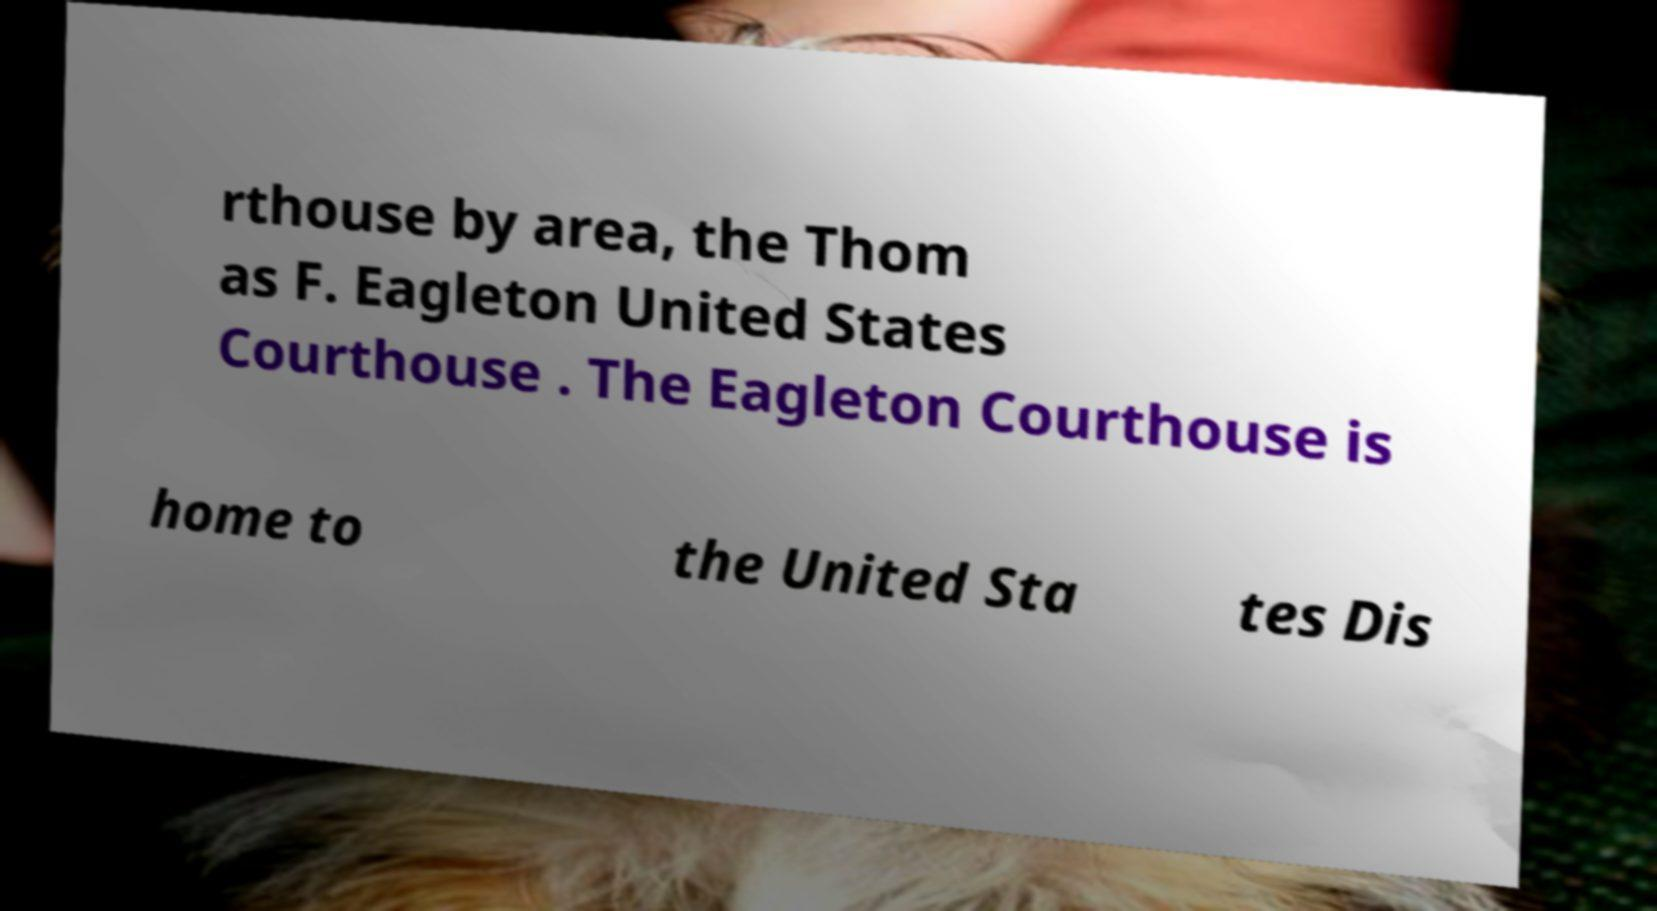Can you accurately transcribe the text from the provided image for me? rthouse by area, the Thom as F. Eagleton United States Courthouse . The Eagleton Courthouse is home to the United Sta tes Dis 